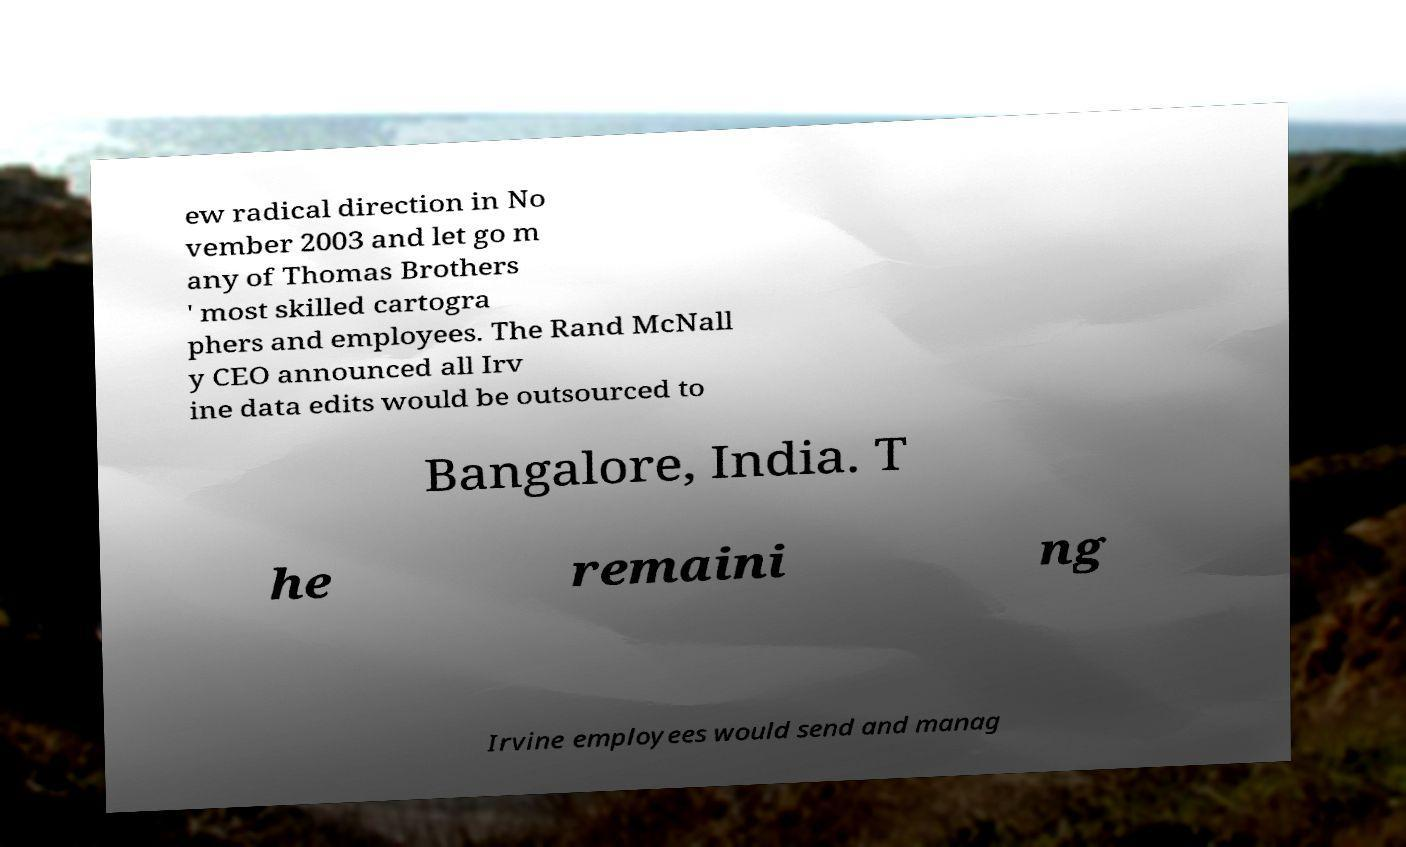For documentation purposes, I need the text within this image transcribed. Could you provide that? ew radical direction in No vember 2003 and let go m any of Thomas Brothers ' most skilled cartogra phers and employees. The Rand McNall y CEO announced all Irv ine data edits would be outsourced to Bangalore, India. T he remaini ng Irvine employees would send and manag 